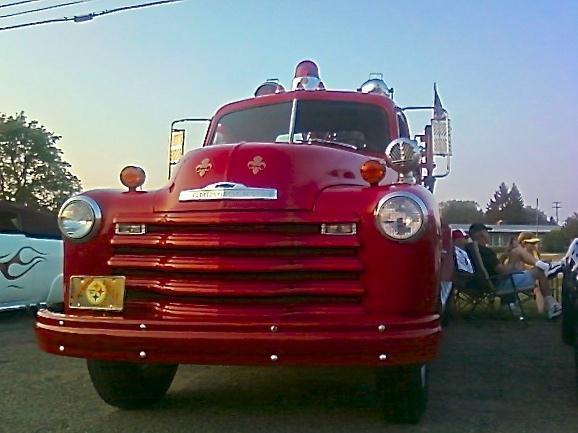How many trucks are there?
Give a very brief answer. 2. How many cats are on the second shelf from the top?
Give a very brief answer. 0. 